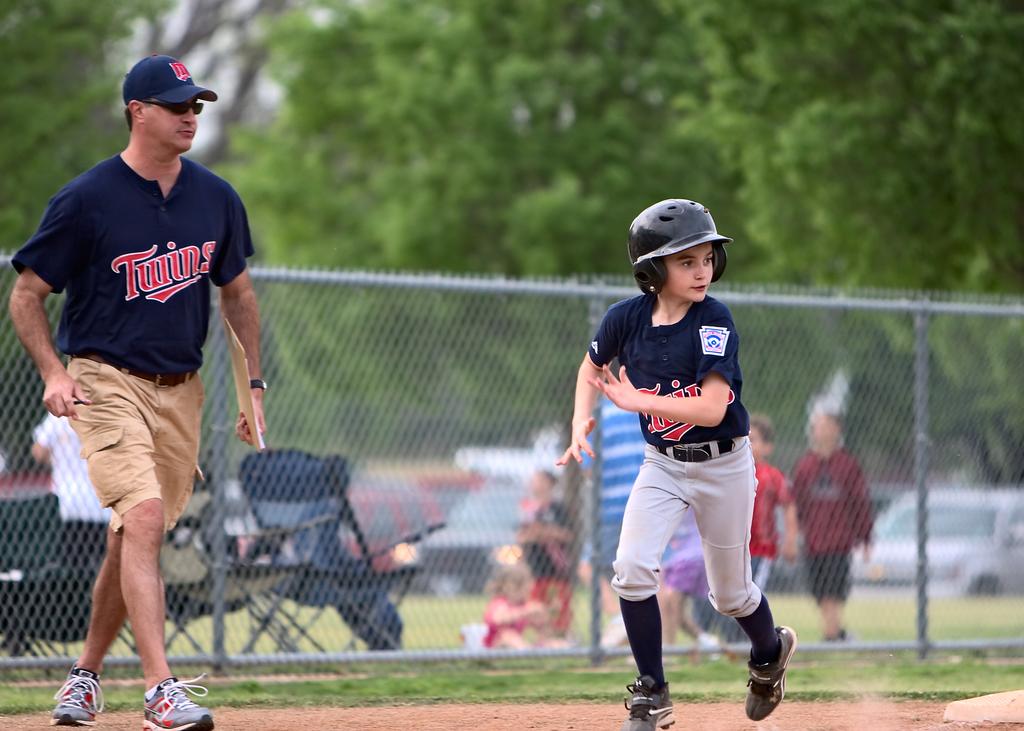What is the baseball team's name?
Provide a short and direct response. Twins. 